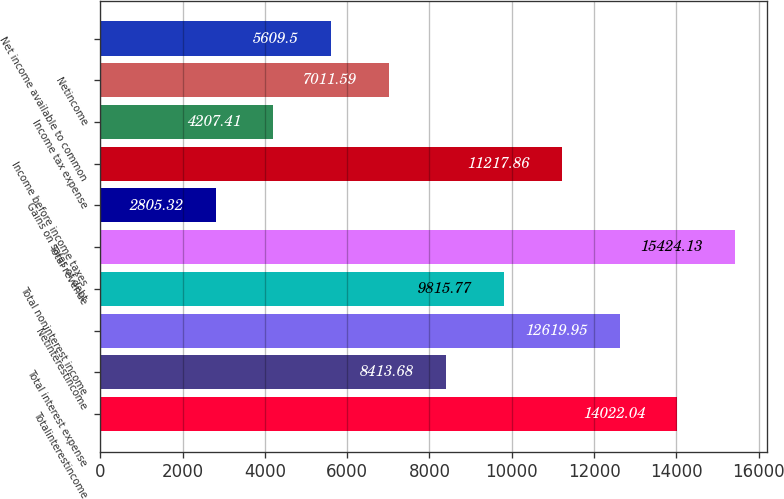Convert chart. <chart><loc_0><loc_0><loc_500><loc_500><bar_chart><fcel>Totalinterestincome<fcel>Total interest expense<fcel>Netinterestincome<fcel>Total noninterest income<fcel>Total revenue<fcel>Gains on sales of debt<fcel>Income before income taxes<fcel>Income tax expense<fcel>Netincome<fcel>Net income available to common<nl><fcel>14022<fcel>8413.68<fcel>12620<fcel>9815.77<fcel>15424.1<fcel>2805.32<fcel>11217.9<fcel>4207.41<fcel>7011.59<fcel>5609.5<nl></chart> 